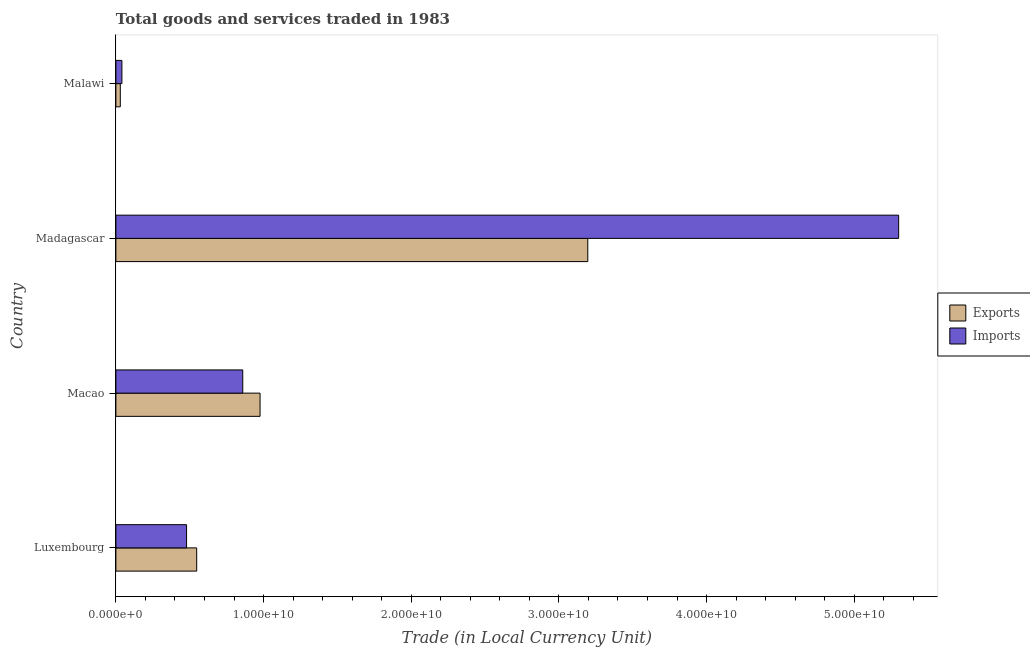Are the number of bars per tick equal to the number of legend labels?
Ensure brevity in your answer.  Yes. How many bars are there on the 2nd tick from the top?
Your response must be concise. 2. How many bars are there on the 1st tick from the bottom?
Offer a terse response. 2. What is the label of the 1st group of bars from the top?
Provide a succinct answer. Malawi. What is the export of goods and services in Macao?
Your response must be concise. 9.76e+09. Across all countries, what is the maximum imports of goods and services?
Provide a short and direct response. 5.30e+1. Across all countries, what is the minimum imports of goods and services?
Make the answer very short. 4.07e+08. In which country was the imports of goods and services maximum?
Offer a terse response. Madagascar. In which country was the imports of goods and services minimum?
Your response must be concise. Malawi. What is the total export of goods and services in the graph?
Your answer should be compact. 4.75e+1. What is the difference between the imports of goods and services in Luxembourg and that in Madagascar?
Your response must be concise. -4.82e+1. What is the difference between the imports of goods and services in Luxembourg and the export of goods and services in Malawi?
Your answer should be compact. 4.49e+09. What is the average imports of goods and services per country?
Give a very brief answer. 1.67e+1. What is the difference between the export of goods and services and imports of goods and services in Luxembourg?
Give a very brief answer. 6.86e+08. In how many countries, is the export of goods and services greater than 18000000000 LCU?
Ensure brevity in your answer.  1. What is the ratio of the export of goods and services in Luxembourg to that in Madagascar?
Your answer should be very brief. 0.17. What is the difference between the highest and the second highest export of goods and services?
Offer a very short reply. 2.22e+1. What is the difference between the highest and the lowest export of goods and services?
Ensure brevity in your answer.  3.17e+1. In how many countries, is the imports of goods and services greater than the average imports of goods and services taken over all countries?
Your answer should be compact. 1. What does the 2nd bar from the top in Malawi represents?
Offer a terse response. Exports. What does the 1st bar from the bottom in Madagascar represents?
Offer a terse response. Exports. How many bars are there?
Your response must be concise. 8. Are all the bars in the graph horizontal?
Offer a terse response. Yes. Are the values on the major ticks of X-axis written in scientific E-notation?
Provide a short and direct response. Yes. Does the graph contain any zero values?
Your response must be concise. No. Where does the legend appear in the graph?
Your response must be concise. Center right. How many legend labels are there?
Make the answer very short. 2. What is the title of the graph?
Give a very brief answer. Total goods and services traded in 1983. Does "Number of arrivals" appear as one of the legend labels in the graph?
Keep it short and to the point. No. What is the label or title of the X-axis?
Ensure brevity in your answer.  Trade (in Local Currency Unit). What is the Trade (in Local Currency Unit) of Exports in Luxembourg?
Your answer should be compact. 5.47e+09. What is the Trade (in Local Currency Unit) in Imports in Luxembourg?
Give a very brief answer. 4.79e+09. What is the Trade (in Local Currency Unit) in Exports in Macao?
Your answer should be very brief. 9.76e+09. What is the Trade (in Local Currency Unit) in Imports in Macao?
Ensure brevity in your answer.  8.59e+09. What is the Trade (in Local Currency Unit) of Exports in Madagascar?
Offer a very short reply. 3.20e+1. What is the Trade (in Local Currency Unit) in Imports in Madagascar?
Ensure brevity in your answer.  5.30e+1. What is the Trade (in Local Currency Unit) of Exports in Malawi?
Keep it short and to the point. 2.98e+08. What is the Trade (in Local Currency Unit) in Imports in Malawi?
Your answer should be very brief. 4.07e+08. Across all countries, what is the maximum Trade (in Local Currency Unit) in Exports?
Offer a very short reply. 3.20e+1. Across all countries, what is the maximum Trade (in Local Currency Unit) of Imports?
Ensure brevity in your answer.  5.30e+1. Across all countries, what is the minimum Trade (in Local Currency Unit) in Exports?
Offer a very short reply. 2.98e+08. Across all countries, what is the minimum Trade (in Local Currency Unit) of Imports?
Your response must be concise. 4.07e+08. What is the total Trade (in Local Currency Unit) in Exports in the graph?
Provide a succinct answer. 4.75e+1. What is the total Trade (in Local Currency Unit) in Imports in the graph?
Provide a succinct answer. 6.68e+1. What is the difference between the Trade (in Local Currency Unit) of Exports in Luxembourg and that in Macao?
Provide a short and direct response. -4.29e+09. What is the difference between the Trade (in Local Currency Unit) of Imports in Luxembourg and that in Macao?
Your answer should be very brief. -3.81e+09. What is the difference between the Trade (in Local Currency Unit) of Exports in Luxembourg and that in Madagascar?
Make the answer very short. -2.65e+1. What is the difference between the Trade (in Local Currency Unit) in Imports in Luxembourg and that in Madagascar?
Make the answer very short. -4.82e+1. What is the difference between the Trade (in Local Currency Unit) of Exports in Luxembourg and that in Malawi?
Keep it short and to the point. 5.17e+09. What is the difference between the Trade (in Local Currency Unit) of Imports in Luxembourg and that in Malawi?
Offer a terse response. 4.38e+09. What is the difference between the Trade (in Local Currency Unit) in Exports in Macao and that in Madagascar?
Offer a terse response. -2.22e+1. What is the difference between the Trade (in Local Currency Unit) in Imports in Macao and that in Madagascar?
Ensure brevity in your answer.  -4.44e+1. What is the difference between the Trade (in Local Currency Unit) in Exports in Macao and that in Malawi?
Give a very brief answer. 9.46e+09. What is the difference between the Trade (in Local Currency Unit) in Imports in Macao and that in Malawi?
Make the answer very short. 8.18e+09. What is the difference between the Trade (in Local Currency Unit) of Exports in Madagascar and that in Malawi?
Offer a very short reply. 3.17e+1. What is the difference between the Trade (in Local Currency Unit) of Imports in Madagascar and that in Malawi?
Ensure brevity in your answer.  5.26e+1. What is the difference between the Trade (in Local Currency Unit) in Exports in Luxembourg and the Trade (in Local Currency Unit) in Imports in Macao?
Your response must be concise. -3.12e+09. What is the difference between the Trade (in Local Currency Unit) of Exports in Luxembourg and the Trade (in Local Currency Unit) of Imports in Madagascar?
Your answer should be very brief. -4.75e+1. What is the difference between the Trade (in Local Currency Unit) of Exports in Luxembourg and the Trade (in Local Currency Unit) of Imports in Malawi?
Give a very brief answer. 5.06e+09. What is the difference between the Trade (in Local Currency Unit) of Exports in Macao and the Trade (in Local Currency Unit) of Imports in Madagascar?
Give a very brief answer. -4.32e+1. What is the difference between the Trade (in Local Currency Unit) of Exports in Macao and the Trade (in Local Currency Unit) of Imports in Malawi?
Provide a succinct answer. 9.36e+09. What is the difference between the Trade (in Local Currency Unit) of Exports in Madagascar and the Trade (in Local Currency Unit) of Imports in Malawi?
Your answer should be compact. 3.15e+1. What is the average Trade (in Local Currency Unit) of Exports per country?
Provide a succinct answer. 1.19e+1. What is the average Trade (in Local Currency Unit) of Imports per country?
Ensure brevity in your answer.  1.67e+1. What is the difference between the Trade (in Local Currency Unit) in Exports and Trade (in Local Currency Unit) in Imports in Luxembourg?
Your response must be concise. 6.86e+08. What is the difference between the Trade (in Local Currency Unit) of Exports and Trade (in Local Currency Unit) of Imports in Macao?
Your answer should be compact. 1.17e+09. What is the difference between the Trade (in Local Currency Unit) of Exports and Trade (in Local Currency Unit) of Imports in Madagascar?
Keep it short and to the point. -2.11e+1. What is the difference between the Trade (in Local Currency Unit) in Exports and Trade (in Local Currency Unit) in Imports in Malawi?
Your answer should be compact. -1.09e+08. What is the ratio of the Trade (in Local Currency Unit) in Exports in Luxembourg to that in Macao?
Provide a short and direct response. 0.56. What is the ratio of the Trade (in Local Currency Unit) in Imports in Luxembourg to that in Macao?
Offer a very short reply. 0.56. What is the ratio of the Trade (in Local Currency Unit) in Exports in Luxembourg to that in Madagascar?
Make the answer very short. 0.17. What is the ratio of the Trade (in Local Currency Unit) of Imports in Luxembourg to that in Madagascar?
Your answer should be very brief. 0.09. What is the ratio of the Trade (in Local Currency Unit) in Exports in Luxembourg to that in Malawi?
Give a very brief answer. 18.35. What is the ratio of the Trade (in Local Currency Unit) in Imports in Luxembourg to that in Malawi?
Keep it short and to the point. 11.76. What is the ratio of the Trade (in Local Currency Unit) in Exports in Macao to that in Madagascar?
Your response must be concise. 0.31. What is the ratio of the Trade (in Local Currency Unit) in Imports in Macao to that in Madagascar?
Your answer should be compact. 0.16. What is the ratio of the Trade (in Local Currency Unit) of Exports in Macao to that in Malawi?
Offer a terse response. 32.74. What is the ratio of the Trade (in Local Currency Unit) of Imports in Macao to that in Malawi?
Your answer should be compact. 21.11. What is the ratio of the Trade (in Local Currency Unit) of Exports in Madagascar to that in Malawi?
Offer a very short reply. 107.16. What is the ratio of the Trade (in Local Currency Unit) of Imports in Madagascar to that in Malawi?
Make the answer very short. 130.24. What is the difference between the highest and the second highest Trade (in Local Currency Unit) in Exports?
Your response must be concise. 2.22e+1. What is the difference between the highest and the second highest Trade (in Local Currency Unit) in Imports?
Your answer should be compact. 4.44e+1. What is the difference between the highest and the lowest Trade (in Local Currency Unit) in Exports?
Provide a succinct answer. 3.17e+1. What is the difference between the highest and the lowest Trade (in Local Currency Unit) in Imports?
Your response must be concise. 5.26e+1. 